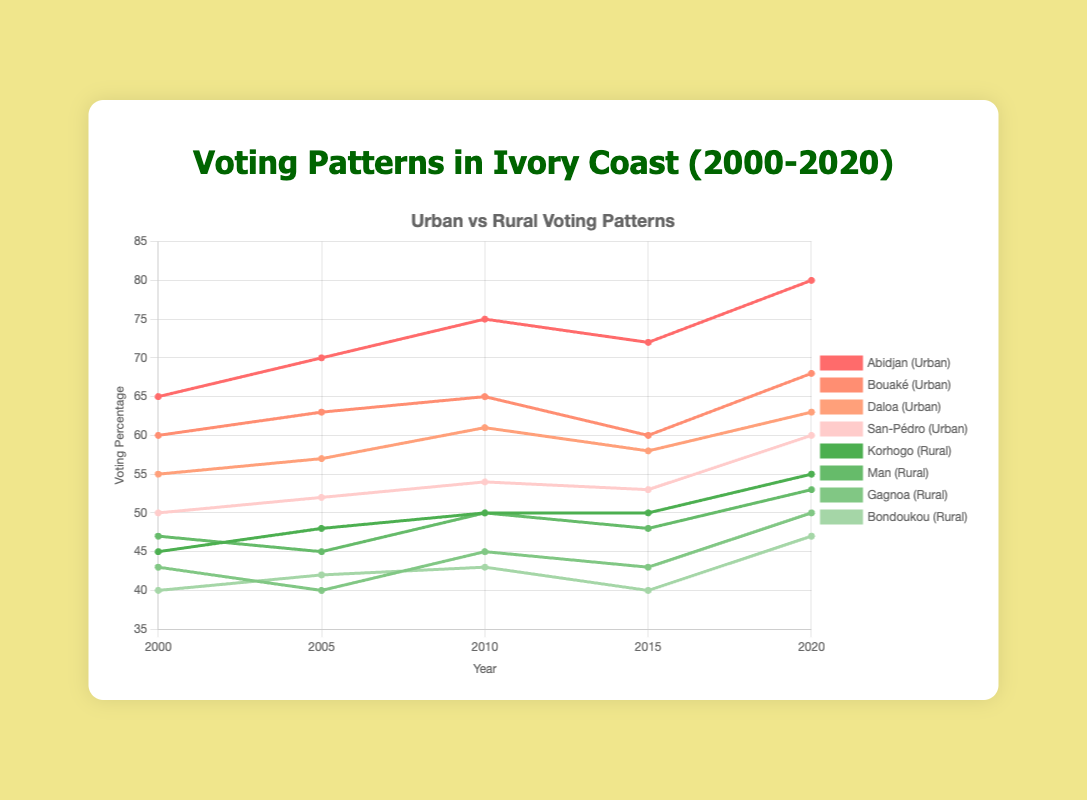What is the voting percentage for Abidjan in 2020? The figure shows the voting percentage for Abidjan in different years. For 2020, locate the point corresponding to Abidjan on the plot and read off the value.
Answer: 80 Which rural area had the lowest voting percentage in 2015? Check the figure for the lowest point among the rural areas (Korhogo, Man, Gagnoa, Bondoukou) for the year 2015. Identify which area this point corresponds to.
Answer: Bondoukou How did the voting percentage in Daloa change from 2000 to 2010? To find the change, look at the values for Daloa in 2000 and 2010 and calculate the difference. In 2000, it was 55%, and in 2010, it was 61%. So, the change is 61% - 55%.
Answer: 6% Was the urban or rural area trend upward from 2000 to 2020 overall? Examine the overall slopes of the lines for both urban and rural areas between 2000 and 2020. If the trend lines slope upwards, that indicates an upward trend.
Answer: Both Among the urban areas, which city had the highest increase in voting percentage from 2005 to 2020? Calculate the increase for each urban city by subtracting the 2005 value from the 2020 value and then compare these increases. For Abidjan (80-70=10), Bouaké (68-63=5), Daloa (63-57=6), San-Pédro (60-52=8).
Answer: Abidjan Which area had a higher voting percentage, Bouaké or Korhogo, in 2010? Check the voting percentages for Bouaké and Korhogo in 2010 from the chart, where Bouaké is 65% and Korhogo is 50%, and then compare these values.
Answer: Bouaké What was the average voting percentage in urban areas in 2020? Add the voting percentages of all urban areas in 2020 (80 for Abidjan, 68 for Bouaké, 63 for Daloa, 60 for San-Pédro) and divide by the number of urban areas. (80 + 68 + 63 + 60) / 4
Answer: 67.75 In which year did Man have the highest voting percentage? Look at the plot and see the data points for Man over different years. Note down the highest point and its corresponding year.
Answer: 2010 Comparing Gagnoa and San-Pédro, which had a smaller change in voting percentage from 2000 to 2020? Calculate the change for both: for Gagnoa (50-43=7) and San-Pédro (60-50=10). The smaller change is for Gagnoa.
Answer: Gagnoa 